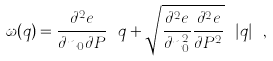Convert formula to latex. <formula><loc_0><loc_0><loc_500><loc_500>\omega ( q ) = \frac { \partial ^ { 2 } e } { \partial n _ { 0 } \partial P } \ q + \sqrt { \frac { \partial ^ { 2 } e } { \partial n _ { 0 } ^ { 2 } } \frac { \partial ^ { 2 } e } { \partial P ^ { 2 } } } \ | q | \ ,</formula> 